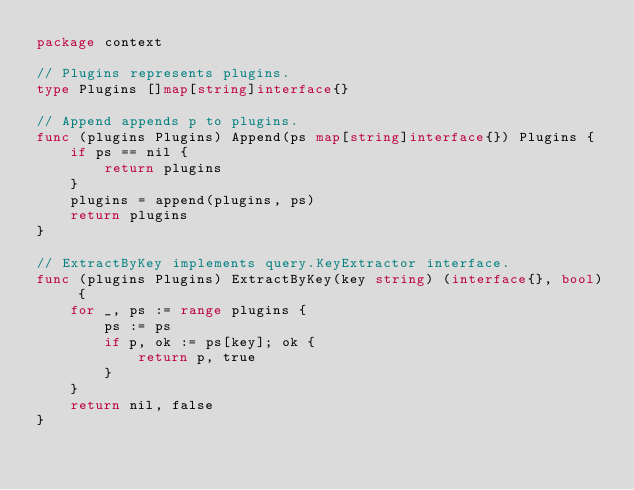Convert code to text. <code><loc_0><loc_0><loc_500><loc_500><_Go_>package context

// Plugins represents plugins.
type Plugins []map[string]interface{}

// Append appends p to plugins.
func (plugins Plugins) Append(ps map[string]interface{}) Plugins {
	if ps == nil {
		return plugins
	}
	plugins = append(plugins, ps)
	return plugins
}

// ExtractByKey implements query.KeyExtractor interface.
func (plugins Plugins) ExtractByKey(key string) (interface{}, bool) {
	for _, ps := range plugins {
		ps := ps
		if p, ok := ps[key]; ok {
			return p, true
		}
	}
	return nil, false
}
</code> 